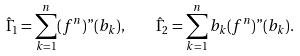Convert formula to latex. <formula><loc_0><loc_0><loc_500><loc_500>\hat { \Gamma } _ { 1 } = \sum _ { k = 1 } ^ { n } ( f ^ { n } ) " ( b _ { k } ) , \quad \hat { \Gamma } _ { 2 } = \sum _ { k = 1 } ^ { n } b _ { k } ( f ^ { n } ) " ( b _ { k } ) .</formula> 